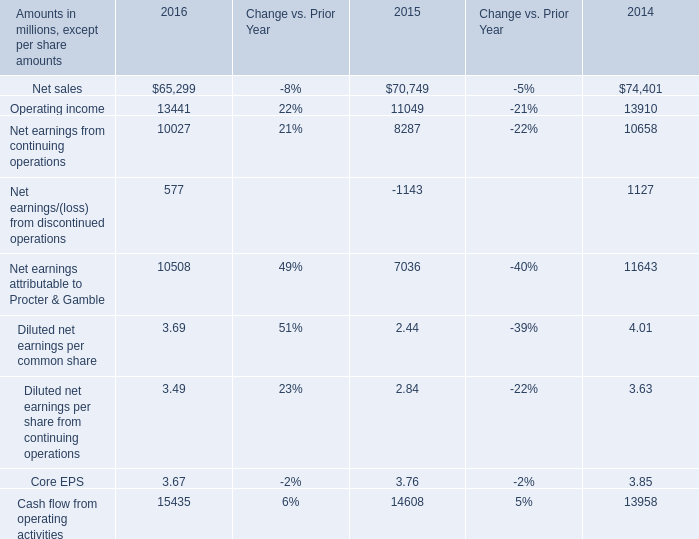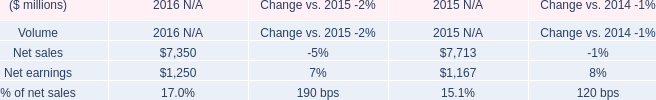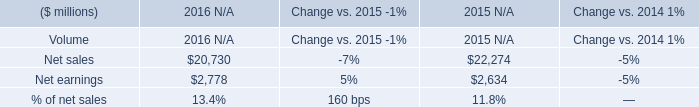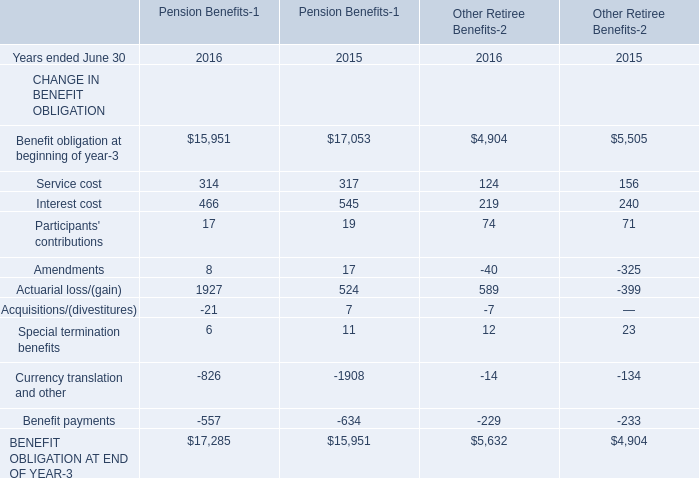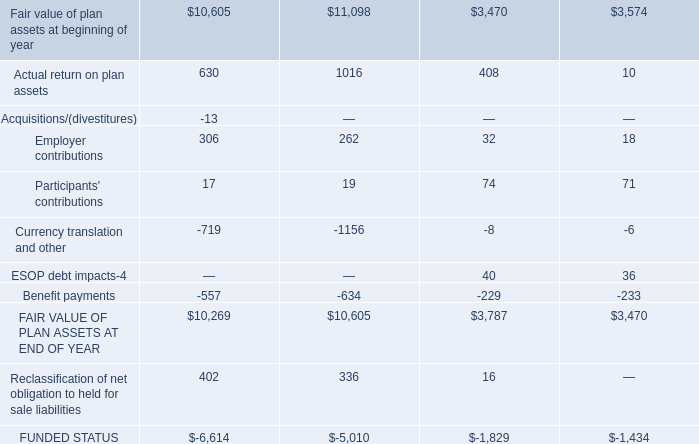What's the sum of the Interest cost in Table 3 in the years where Net sales in Table 1 is greater than 7500? 
Computations: (545 + 240)
Answer: 785.0. 